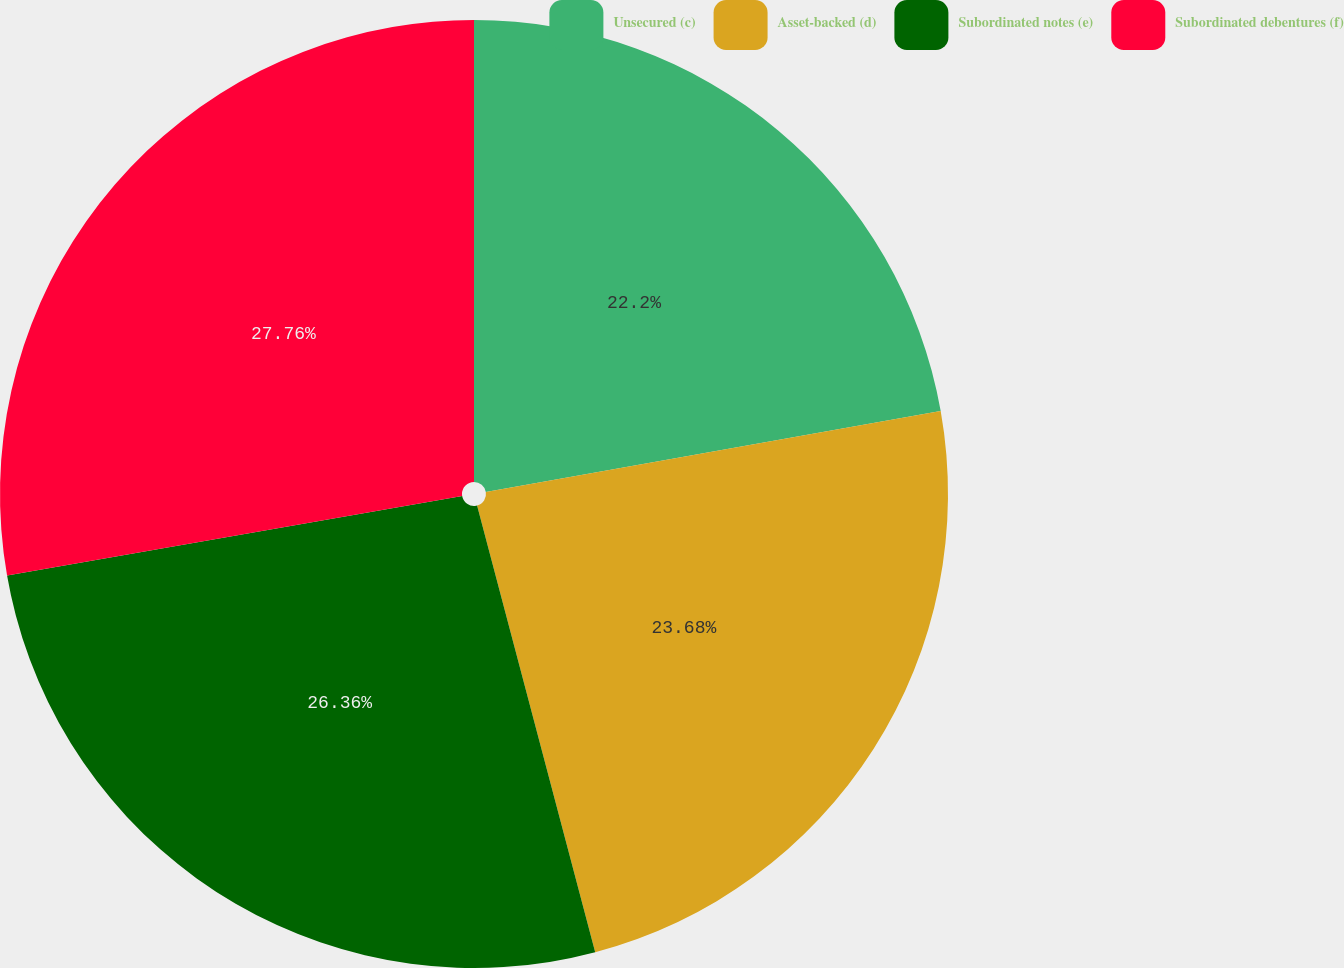Convert chart. <chart><loc_0><loc_0><loc_500><loc_500><pie_chart><fcel>Unsecured (c)<fcel>Asset-backed (d)<fcel>Subordinated notes (e)<fcel>Subordinated debentures (f)<nl><fcel>22.2%<fcel>23.68%<fcel>26.36%<fcel>27.75%<nl></chart> 